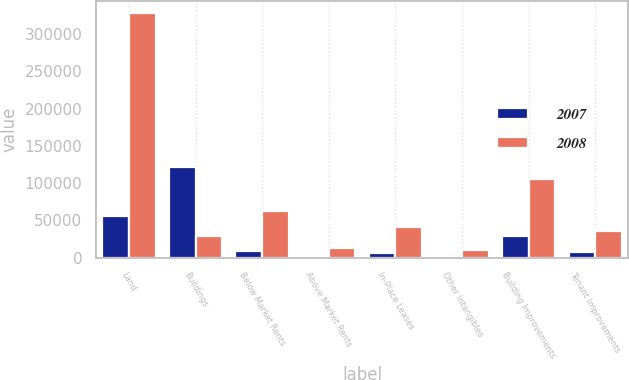<chart> <loc_0><loc_0><loc_500><loc_500><stacked_bar_chart><ecel><fcel>Land<fcel>Buildings<fcel>Below Market Rents<fcel>Above Market Rents<fcel>In-Place Leases<fcel>Other Intangibles<fcel>Building Improvements<fcel>Tenant Improvements<nl><fcel>2007<fcel>55323<fcel>121927<fcel>8926<fcel>2167<fcel>6879<fcel>2739<fcel>28589<fcel>7147<nl><fcel>2008<fcel>327970<fcel>28589<fcel>62802<fcel>13629<fcel>41281<fcel>10181<fcel>105716<fcel>35897<nl></chart> 